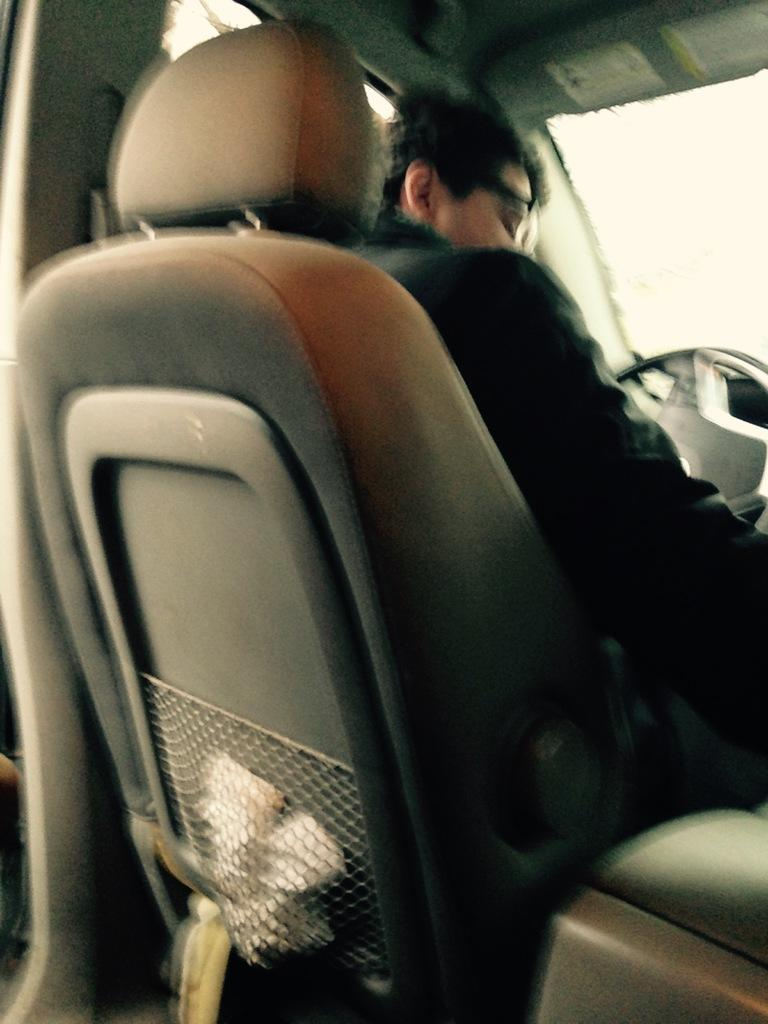What is the setting of the image? The image shows the inside view of a car. Who is present in the car? There is a person sitting in the driving seat. What is the person doing in the image? The person is holding the steering wheel and has their other hand on the gear shift. How does the goat react to the earthquake in the image? There is no goat or earthquake present in the image. 